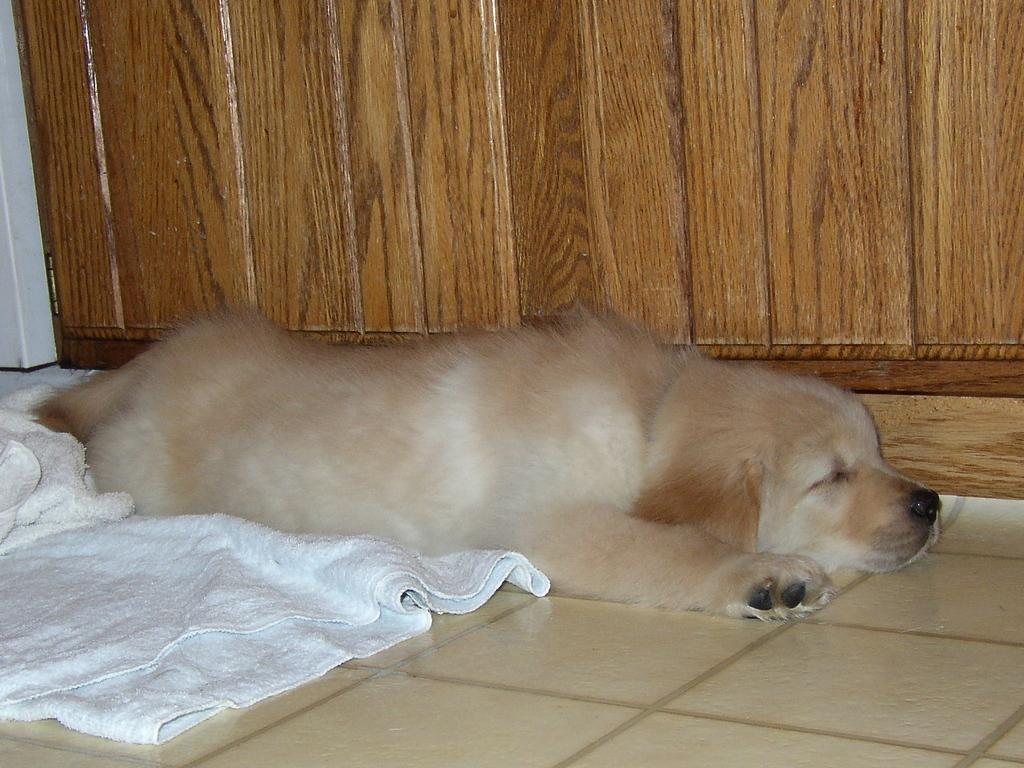What animal can be seen in the image? There is a dog in the image. What is the dog lying on? The dog is lying on a cloth. Where is the cloth placed? The cloth is placed on the floor. What can be seen in the background of the image? There is a cupboard in the background of the image. What type of metal is the dog made of in the image? The dog is not made of metal; it is a living animal. The image shows a real dog lying on a cloth. 